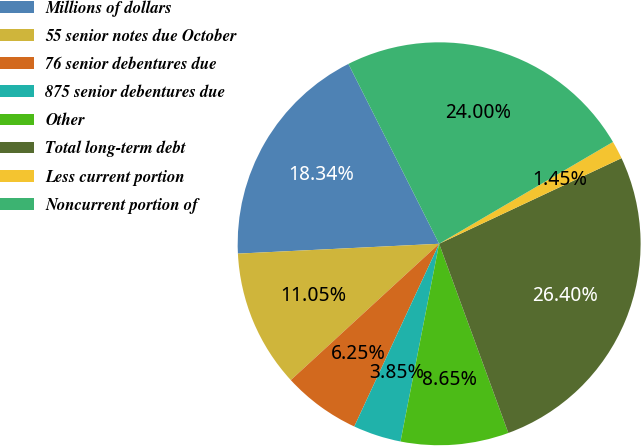Convert chart to OTSL. <chart><loc_0><loc_0><loc_500><loc_500><pie_chart><fcel>Millions of dollars<fcel>55 senior notes due October<fcel>76 senior debentures due<fcel>875 senior debentures due<fcel>Other<fcel>Total long-term debt<fcel>Less current portion<fcel>Noncurrent portion of<nl><fcel>18.34%<fcel>11.05%<fcel>6.25%<fcel>3.85%<fcel>8.65%<fcel>26.4%<fcel>1.45%<fcel>24.0%<nl></chart> 